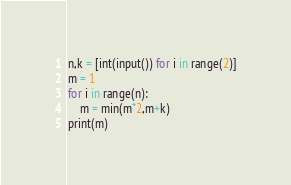Convert code to text. <code><loc_0><loc_0><loc_500><loc_500><_Python_>n,k = [int(input()) for i in range(2)]
m = 1
for i in range(n):
    m = min(m*2,m+k)
print(m)</code> 